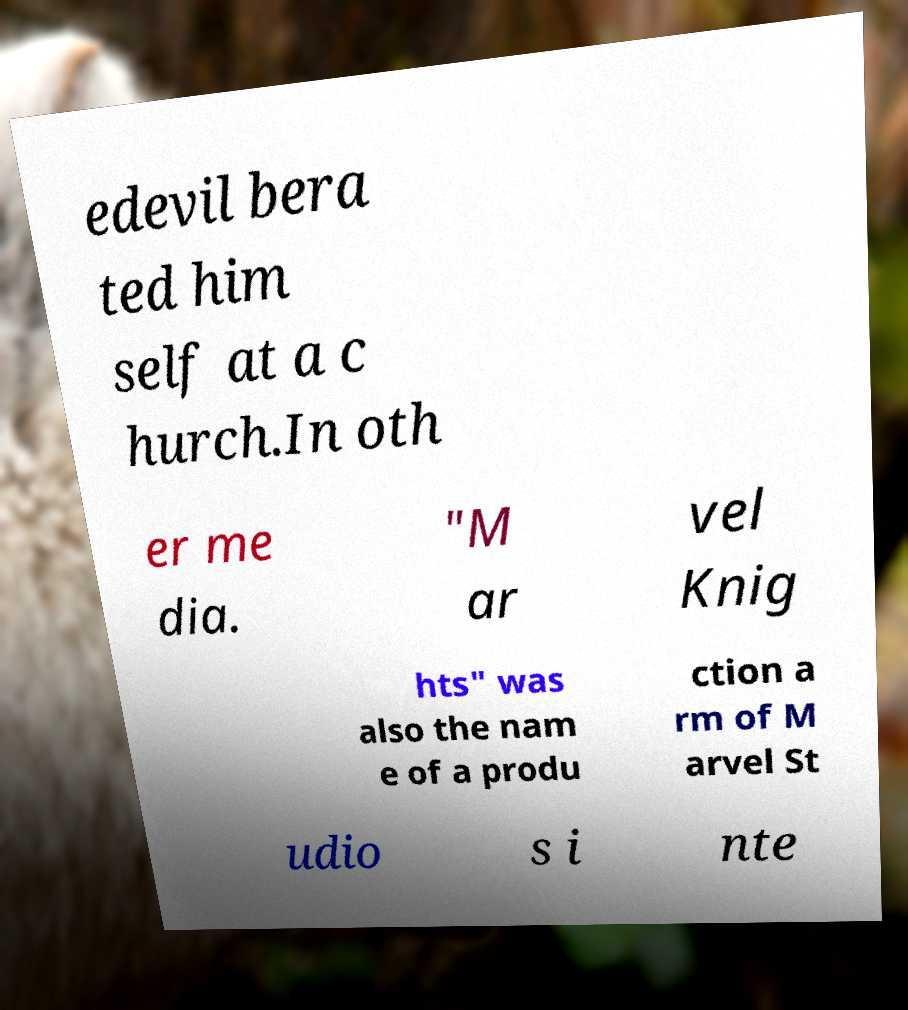I need the written content from this picture converted into text. Can you do that? edevil bera ted him self at a c hurch.In oth er me dia. "M ar vel Knig hts" was also the nam e of a produ ction a rm of M arvel St udio s i nte 